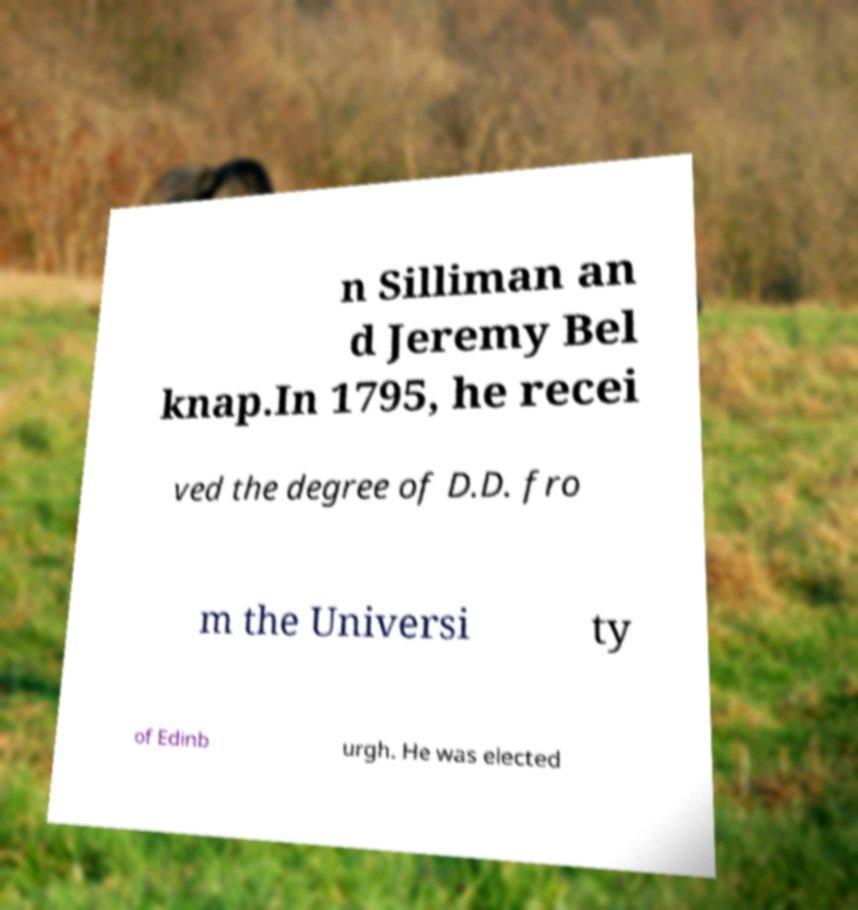For documentation purposes, I need the text within this image transcribed. Could you provide that? n Silliman an d Jeremy Bel knap.In 1795, he recei ved the degree of D.D. fro m the Universi ty of Edinb urgh. He was elected 